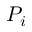<formula> <loc_0><loc_0><loc_500><loc_500>P _ { i }</formula> 